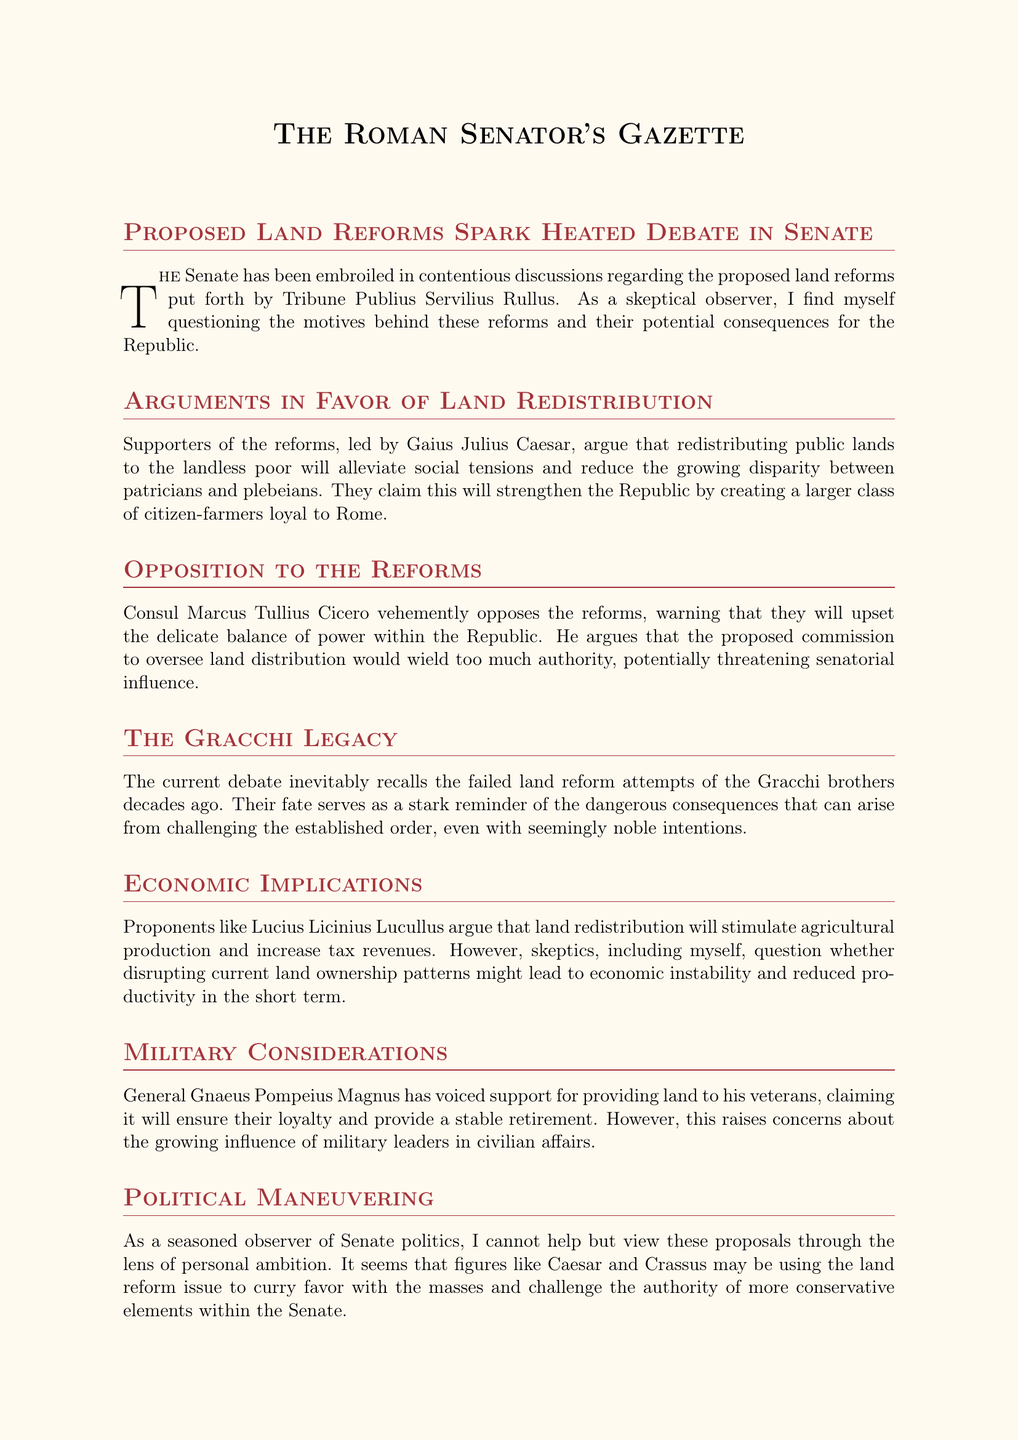What is the title of the newsletter? The title is stated at the beginning of the document, introducing the focus on land reforms and the Senate's debates.
Answer: The Roman Senator's Gazette Who proposed the land reforms? The Tribune Publius Servilius Rullus is credited with putting forth the proposed land reforms discussed in the Senate.
Answer: Tribune Publius Servilius Rullus Which senator argues for land redistribution? Gaius Julius Caesar is highlighted as a leading supporter of the land redistribution reforms.
Answer: Gaius Julius Caesar What warning does Cicero give regarding the reforms? Cicero warns that the reforms may upset the delicate balance of power within the Republic, thus indicating potential consequences of such changes.
Answer: Upend balance of power Which past event is recalled during the debate? The failed land reform attempts of the Gracchi brothers are referenced as a cautionary tale in the current discussions.
Answer: The Gracchi brothers What is one argument made by military leaders in favor of land reforms? General Gnaeus Pompeius Magnus supports land distribution to veterans, asserting it ensures their loyalty and stable retirement.
Answer: Loyalty and stable retirement What type of reforms do moderate senators suggest? Moderate senators propose more limited reforms that would distribute a portion of public lands while maintaining existing ownership structures.
Answer: Limited reforms What concern is raised about military influence? The increasing influence of military leaders in civilian affairs due to land distribution for veterans raises concerns among some senators.
Answer: Growing influence What is a long-term consideration mentioned in relation to the reforms? The potential impact on the foundations of the Republic is considered, questioning whether reforms will enhance stability or empower demagogues.
Answer: Foundations of our Republic 